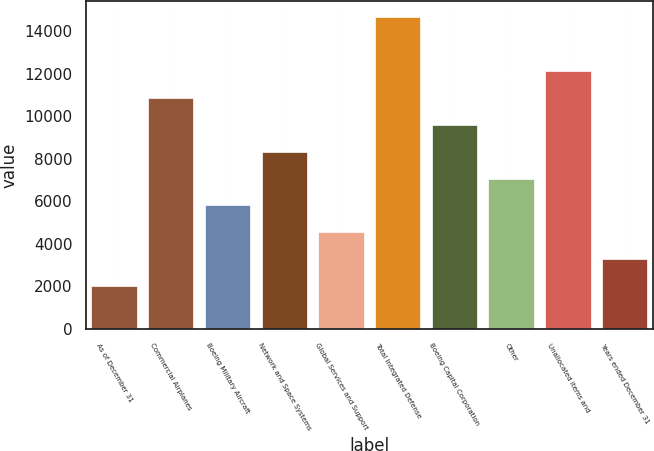Convert chart to OTSL. <chart><loc_0><loc_0><loc_500><loc_500><bar_chart><fcel>As of December 31<fcel>Commercial Airplanes<fcel>Boeing Military Aircraft<fcel>Network and Space Systems<fcel>Global Services and Support<fcel>Total Integrated Defense<fcel>Boeing Capital Corporation<fcel>Other<fcel>Unallocated items and<fcel>Years ended December 31<nl><fcel>2006<fcel>10868<fcel>5804<fcel>8336<fcel>4538<fcel>14666<fcel>9602<fcel>7070<fcel>12134<fcel>3272<nl></chart> 